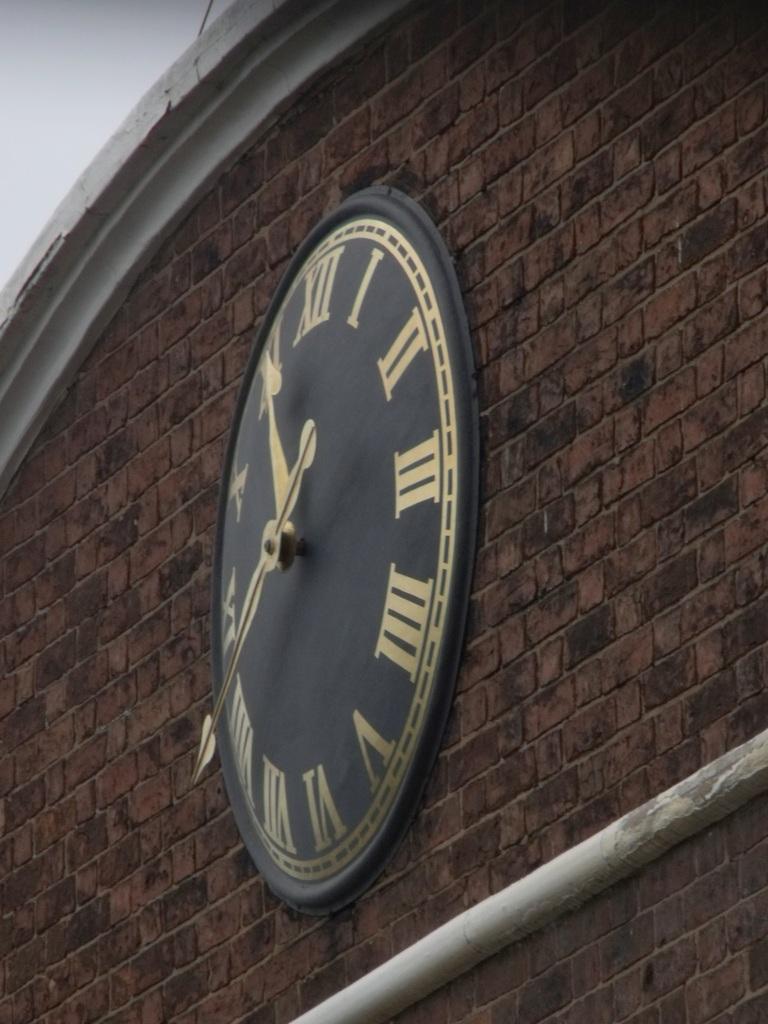What time is it?
Give a very brief answer. 11:40. 